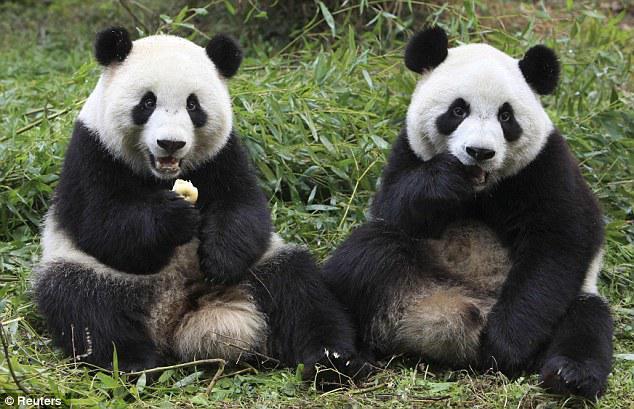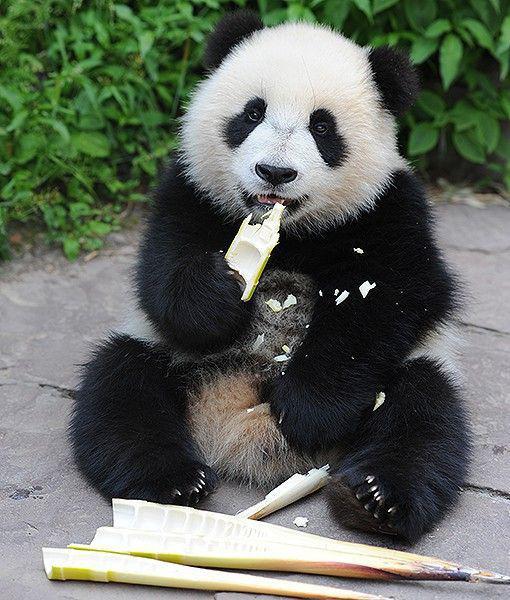The first image is the image on the left, the second image is the image on the right. Assess this claim about the two images: "All pandas are sitting up, and at least one panda is munching on plant material grasped in one paw.". Correct or not? Answer yes or no. Yes. The first image is the image on the left, the second image is the image on the right. Evaluate the accuracy of this statement regarding the images: "The right image contains a panda with bamboo in its mouth.". Is it true? Answer yes or no. Yes. 